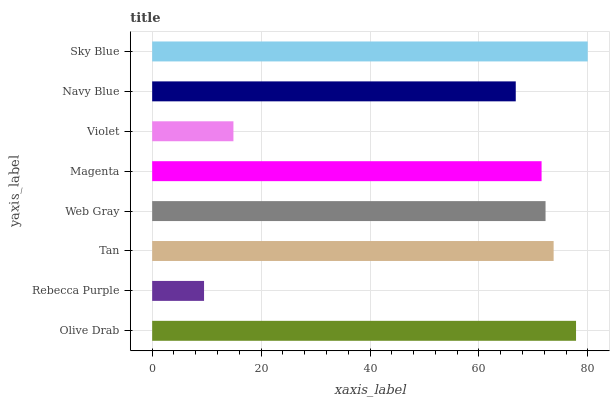Is Rebecca Purple the minimum?
Answer yes or no. Yes. Is Sky Blue the maximum?
Answer yes or no. Yes. Is Tan the minimum?
Answer yes or no. No. Is Tan the maximum?
Answer yes or no. No. Is Tan greater than Rebecca Purple?
Answer yes or no. Yes. Is Rebecca Purple less than Tan?
Answer yes or no. Yes. Is Rebecca Purple greater than Tan?
Answer yes or no. No. Is Tan less than Rebecca Purple?
Answer yes or no. No. Is Web Gray the high median?
Answer yes or no. Yes. Is Magenta the low median?
Answer yes or no. Yes. Is Navy Blue the high median?
Answer yes or no. No. Is Navy Blue the low median?
Answer yes or no. No. 